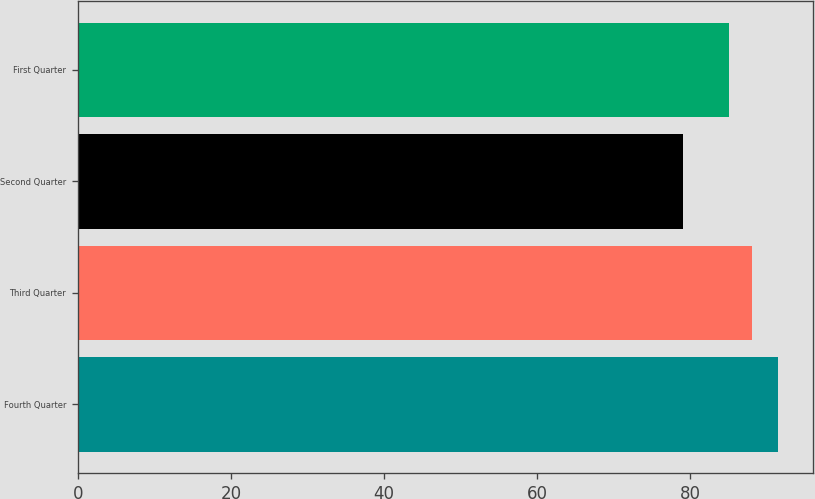<chart> <loc_0><loc_0><loc_500><loc_500><bar_chart><fcel>Fourth Quarter<fcel>Third Quarter<fcel>Second Quarter<fcel>First Quarter<nl><fcel>91.5<fcel>88.11<fcel>79<fcel>85<nl></chart> 